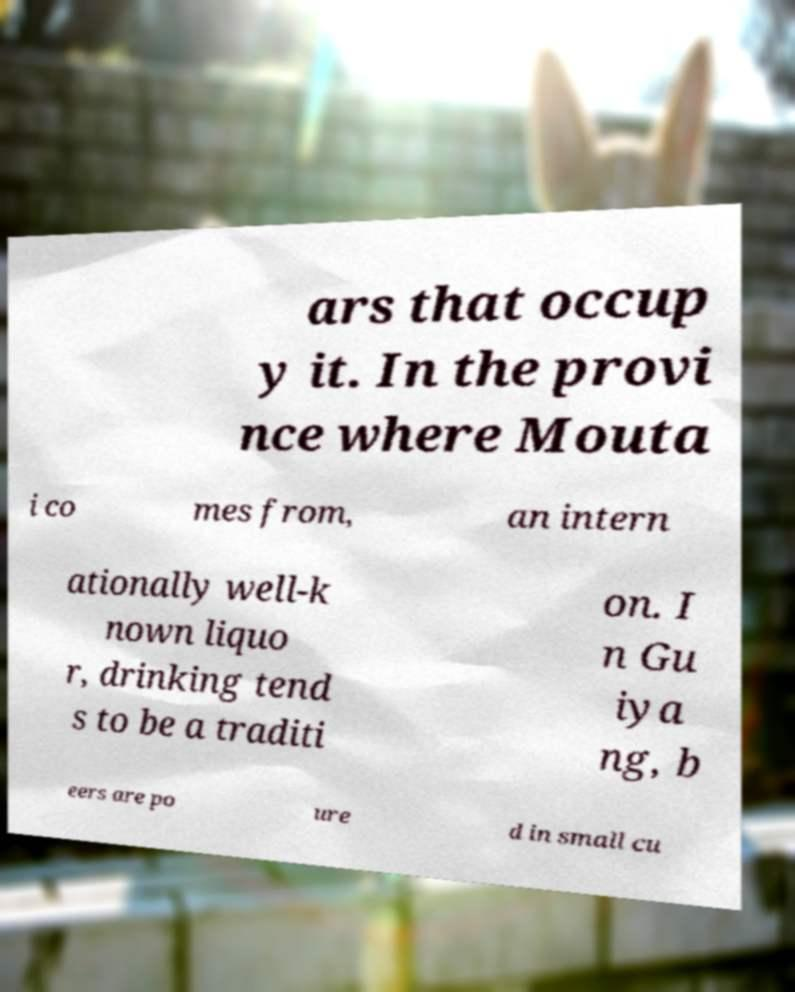There's text embedded in this image that I need extracted. Can you transcribe it verbatim? ars that occup y it. In the provi nce where Mouta i co mes from, an intern ationally well-k nown liquo r, drinking tend s to be a traditi on. I n Gu iya ng, b eers are po ure d in small cu 